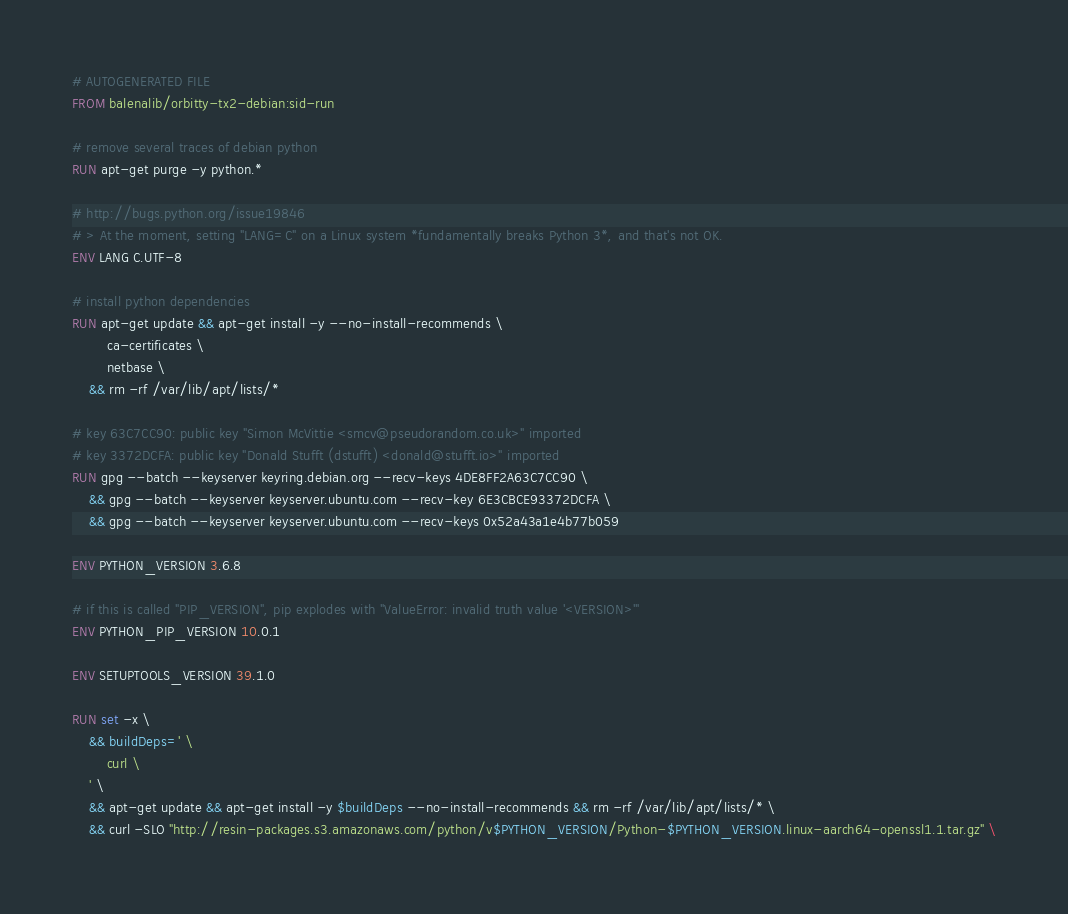Convert code to text. <code><loc_0><loc_0><loc_500><loc_500><_Dockerfile_># AUTOGENERATED FILE
FROM balenalib/orbitty-tx2-debian:sid-run

# remove several traces of debian python
RUN apt-get purge -y python.*

# http://bugs.python.org/issue19846
# > At the moment, setting "LANG=C" on a Linux system *fundamentally breaks Python 3*, and that's not OK.
ENV LANG C.UTF-8

# install python dependencies
RUN apt-get update && apt-get install -y --no-install-recommends \
		ca-certificates \
		netbase \
	&& rm -rf /var/lib/apt/lists/*

# key 63C7CC90: public key "Simon McVittie <smcv@pseudorandom.co.uk>" imported
# key 3372DCFA: public key "Donald Stufft (dstufft) <donald@stufft.io>" imported
RUN gpg --batch --keyserver keyring.debian.org --recv-keys 4DE8FF2A63C7CC90 \
	&& gpg --batch --keyserver keyserver.ubuntu.com --recv-key 6E3CBCE93372DCFA \
	&& gpg --batch --keyserver keyserver.ubuntu.com --recv-keys 0x52a43a1e4b77b059

ENV PYTHON_VERSION 3.6.8

# if this is called "PIP_VERSION", pip explodes with "ValueError: invalid truth value '<VERSION>'"
ENV PYTHON_PIP_VERSION 10.0.1

ENV SETUPTOOLS_VERSION 39.1.0

RUN set -x \
	&& buildDeps=' \
		curl \
	' \
	&& apt-get update && apt-get install -y $buildDeps --no-install-recommends && rm -rf /var/lib/apt/lists/* \
	&& curl -SLO "http://resin-packages.s3.amazonaws.com/python/v$PYTHON_VERSION/Python-$PYTHON_VERSION.linux-aarch64-openssl1.1.tar.gz" \</code> 